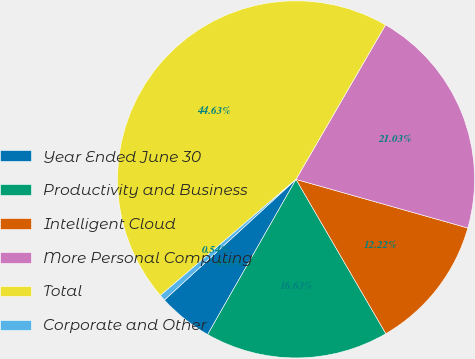<chart> <loc_0><loc_0><loc_500><loc_500><pie_chart><fcel>Year Ended June 30<fcel>Productivity and Business<fcel>Intelligent Cloud<fcel>More Personal Computing<fcel>Total<fcel>Corporate and Other<nl><fcel>4.95%<fcel>16.63%<fcel>12.22%<fcel>21.03%<fcel>44.63%<fcel>0.54%<nl></chart> 